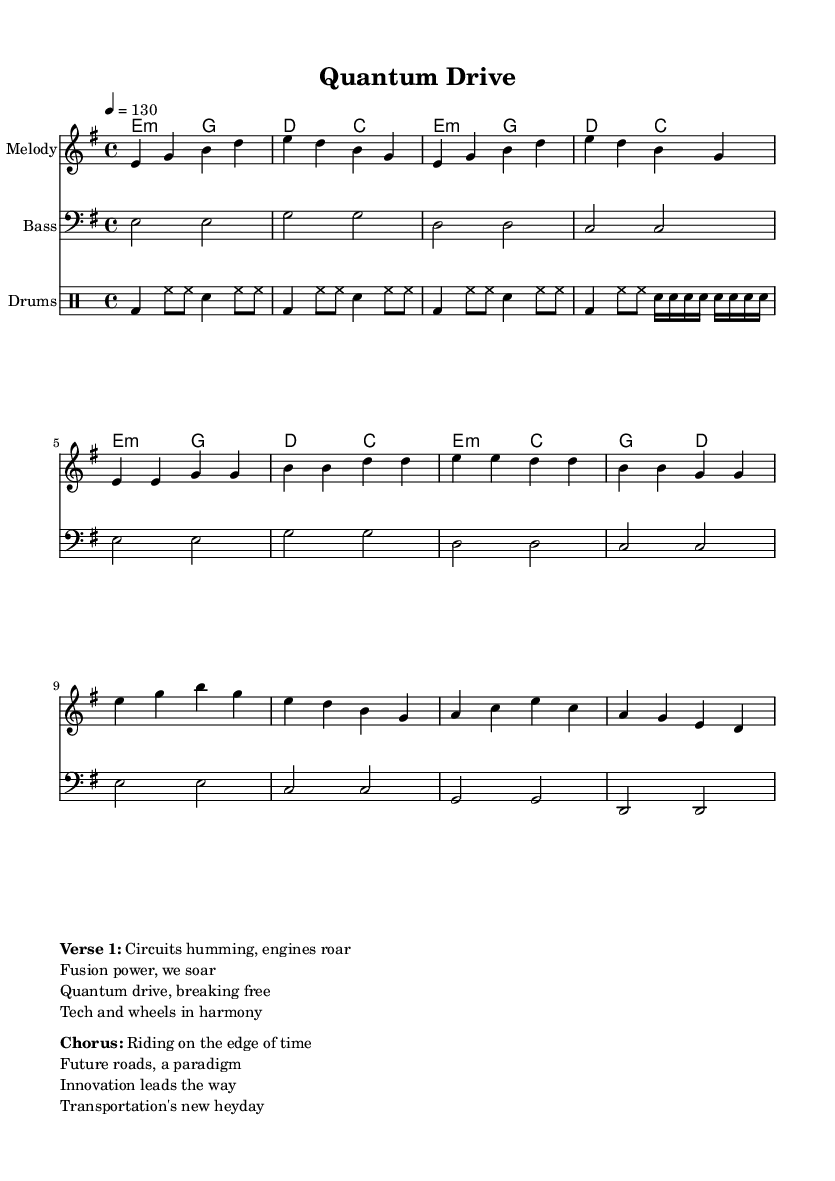What is the time signature of this music? The time signature is found at the beginning of the score and indicates how many beats are in each measure. In this case, it is 4/4, which means there are four beats per measure.
Answer: 4/4 What key is this piece written in? The key signature is indicated in the global section of the score, which shows the key of E minor. This can be inferred from the presence of one sharp (F#) in the key signature.
Answer: E minor How many measures are there in the chorus? To determine the number of measures in the chorus, one needs to look at the sections of the score. The chorus consists of four lines, and each line typically has four measures, leading to a total of four measures in this section.
Answer: 4 What is the tempo marking for this piece? The tempo is specified in the global section of the score as 4 = 130, which means the quarter note is played at a speed of 130 beats per minute.
Answer: 130 How many chords are used in the verse? The verse uses two types of chords according to the harmonies section: E minor and G major. Each chord is repeated throughout the verse section, contributing to the overall structure.
Answer: 2 What is the primary lyrical theme of the song? The lyrics reflect a futuristic theme around technology and transportation, as indicated by the phrases about quantum drive and innovation, suggesting that the song explores possibilities of modern transportation.
Answer: Technology and transportation 